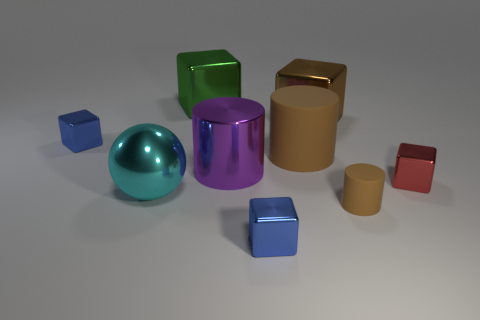What colors are the two smallest objects in the scene? The two smallest objects in this scene are red and blue. 